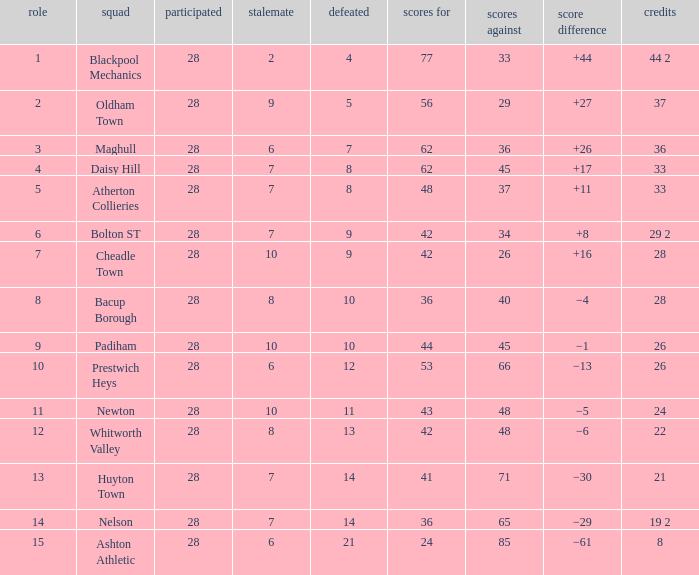What is the highest goals entry with drawn larger than 6 and goals against 85? None. 